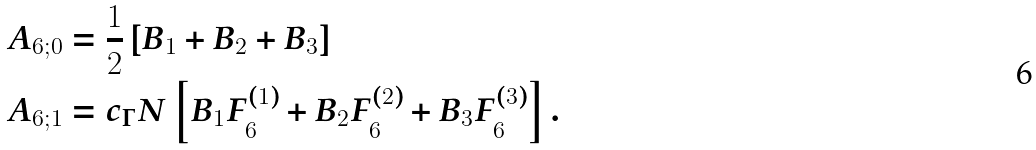<formula> <loc_0><loc_0><loc_500><loc_500>& A _ { 6 ; 0 } = \frac { 1 } { 2 } \left [ B _ { 1 } + B _ { 2 } + B _ { 3 } \right ] \\ & A _ { 6 ; 1 } = c _ { \Gamma } N \left [ B _ { 1 } F _ { 6 } ^ { ( 1 ) } + B _ { 2 } F _ { 6 } ^ { ( 2 ) } + B _ { 3 } F _ { 6 } ^ { ( 3 ) } \right ] .</formula> 